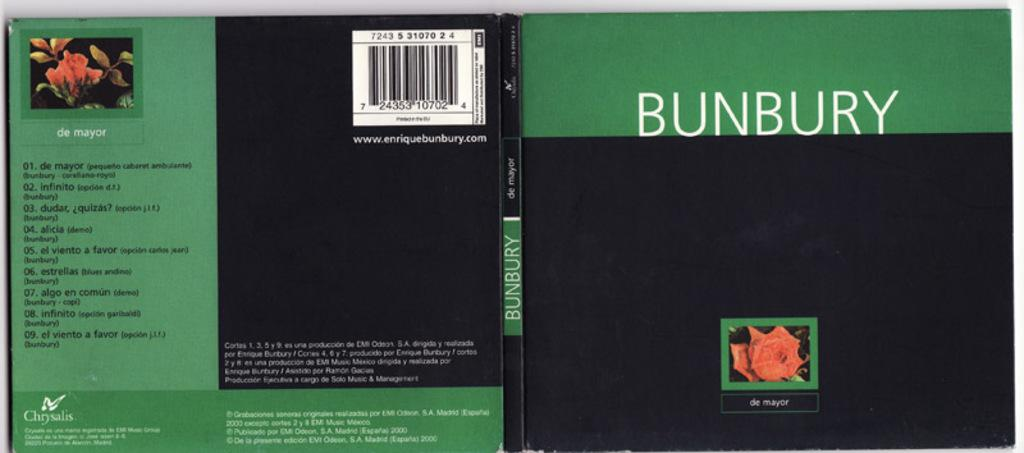<image>
Create a compact narrative representing the image presented. the word Bunbury is on some CD that is green and black 